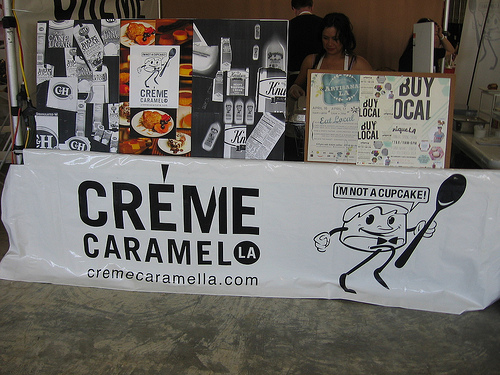<image>
Is there a picture above the table? No. The picture is not positioned above the table. The vertical arrangement shows a different relationship. 